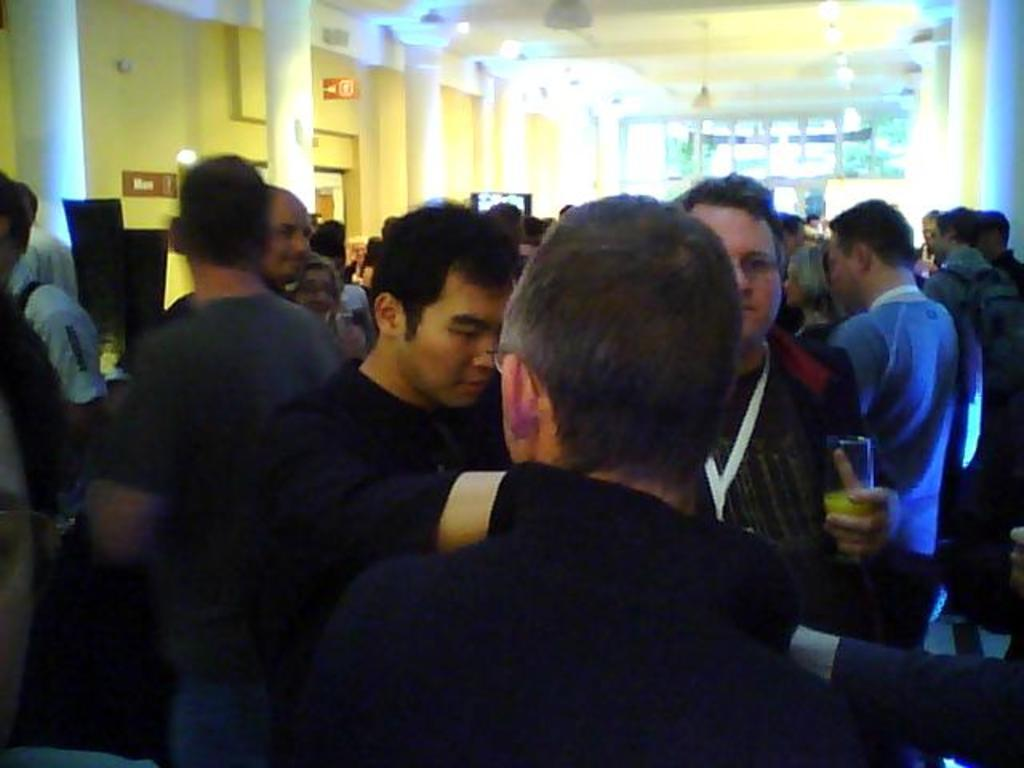How many people can be seen in the image? There are many people standing in the image. What can be seen in the background of the image? There are pillars in the background of the image. What color is the wall in the image? The wall is yellow. What color is the roof in the image? The roof is white. How many apples are being used by the people in the image? There are no apples present in the image. What part of the body is being used by the people in the image? The question is unclear, but the people in the image are standing, so they are likely using their legs and feet to support themselves. 